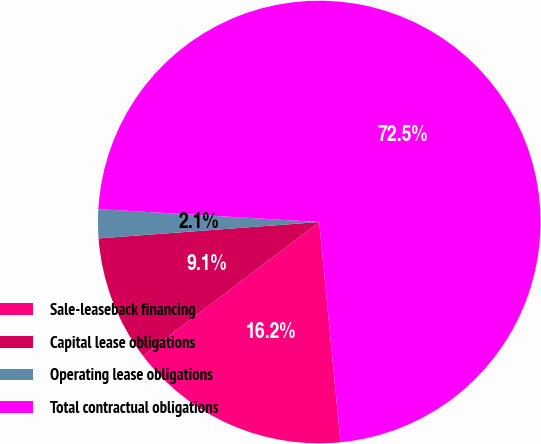Convert chart to OTSL. <chart><loc_0><loc_0><loc_500><loc_500><pie_chart><fcel>Sale-leaseback financing<fcel>Capital lease obligations<fcel>Operating lease obligations<fcel>Total contractual obligations<nl><fcel>16.2%<fcel>9.15%<fcel>2.11%<fcel>72.54%<nl></chart> 